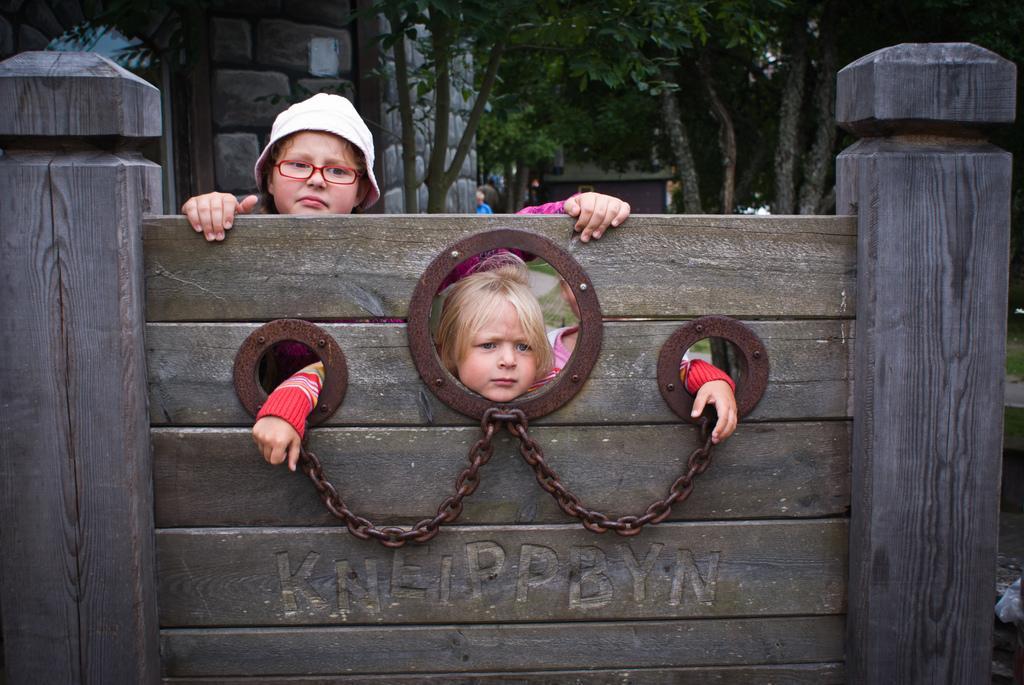How would you summarize this image in a sentence or two? In this image I can see a wooden wall with some text written on it. I can see two people. In the background, I can see the buildings and the trees. 